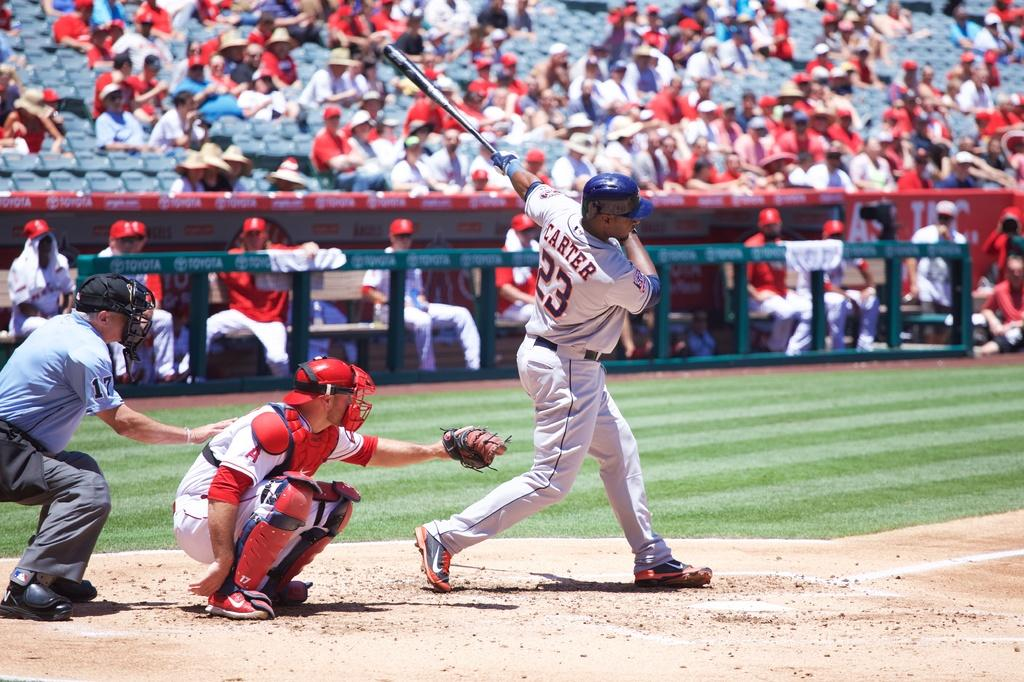<image>
Create a compact narrative representing the image presented. Carter takes a called strike while swinging a bat. 